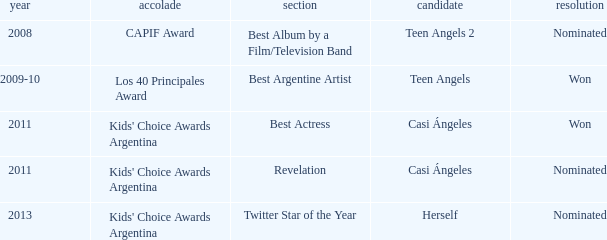What year was there a nomination for Best Actress at the Kids' Choice Awards Argentina? 2011.0. I'm looking to parse the entire table for insights. Could you assist me with that? {'header': ['year', 'accolade', 'section', 'candidate', 'resolution'], 'rows': [['2008', 'CAPIF Award', 'Best Album by a Film/Television Band', 'Teen Angels 2', 'Nominated'], ['2009-10', 'Los 40 Principales Award', 'Best Argentine Artist', 'Teen Angels', 'Won'], ['2011', "Kids' Choice Awards Argentina", 'Best Actress', 'Casi Ángeles', 'Won'], ['2011', "Kids' Choice Awards Argentina", 'Revelation', 'Casi Ángeles', 'Nominated'], ['2013', "Kids' Choice Awards Argentina", 'Twitter Star of the Year', 'Herself', 'Nominated']]} 